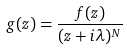<formula> <loc_0><loc_0><loc_500><loc_500>g ( z ) = \frac { f ( z ) } { ( z + i \lambda ) ^ { N } }</formula> 